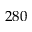Convert formula to latex. <formula><loc_0><loc_0><loc_500><loc_500>2 8 0</formula> 